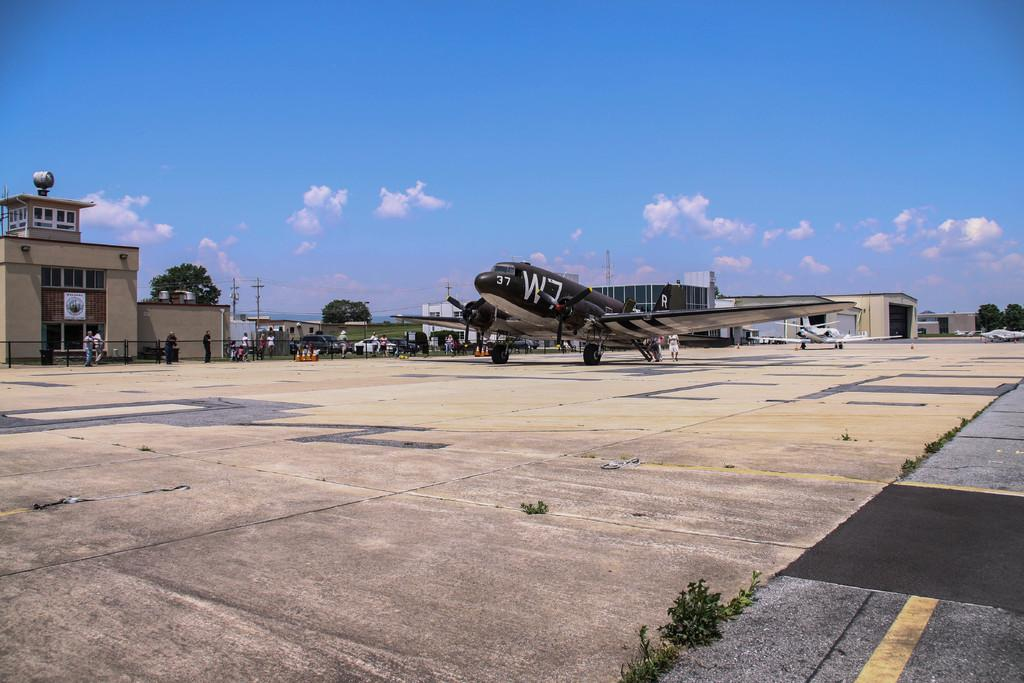<image>
Create a compact narrative representing the image presented. A plane with the numbers 37 written on the front 